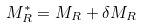Convert formula to latex. <formula><loc_0><loc_0><loc_500><loc_500>M ^ { * } _ { R } = M _ { R } + \delta M _ { R }</formula> 